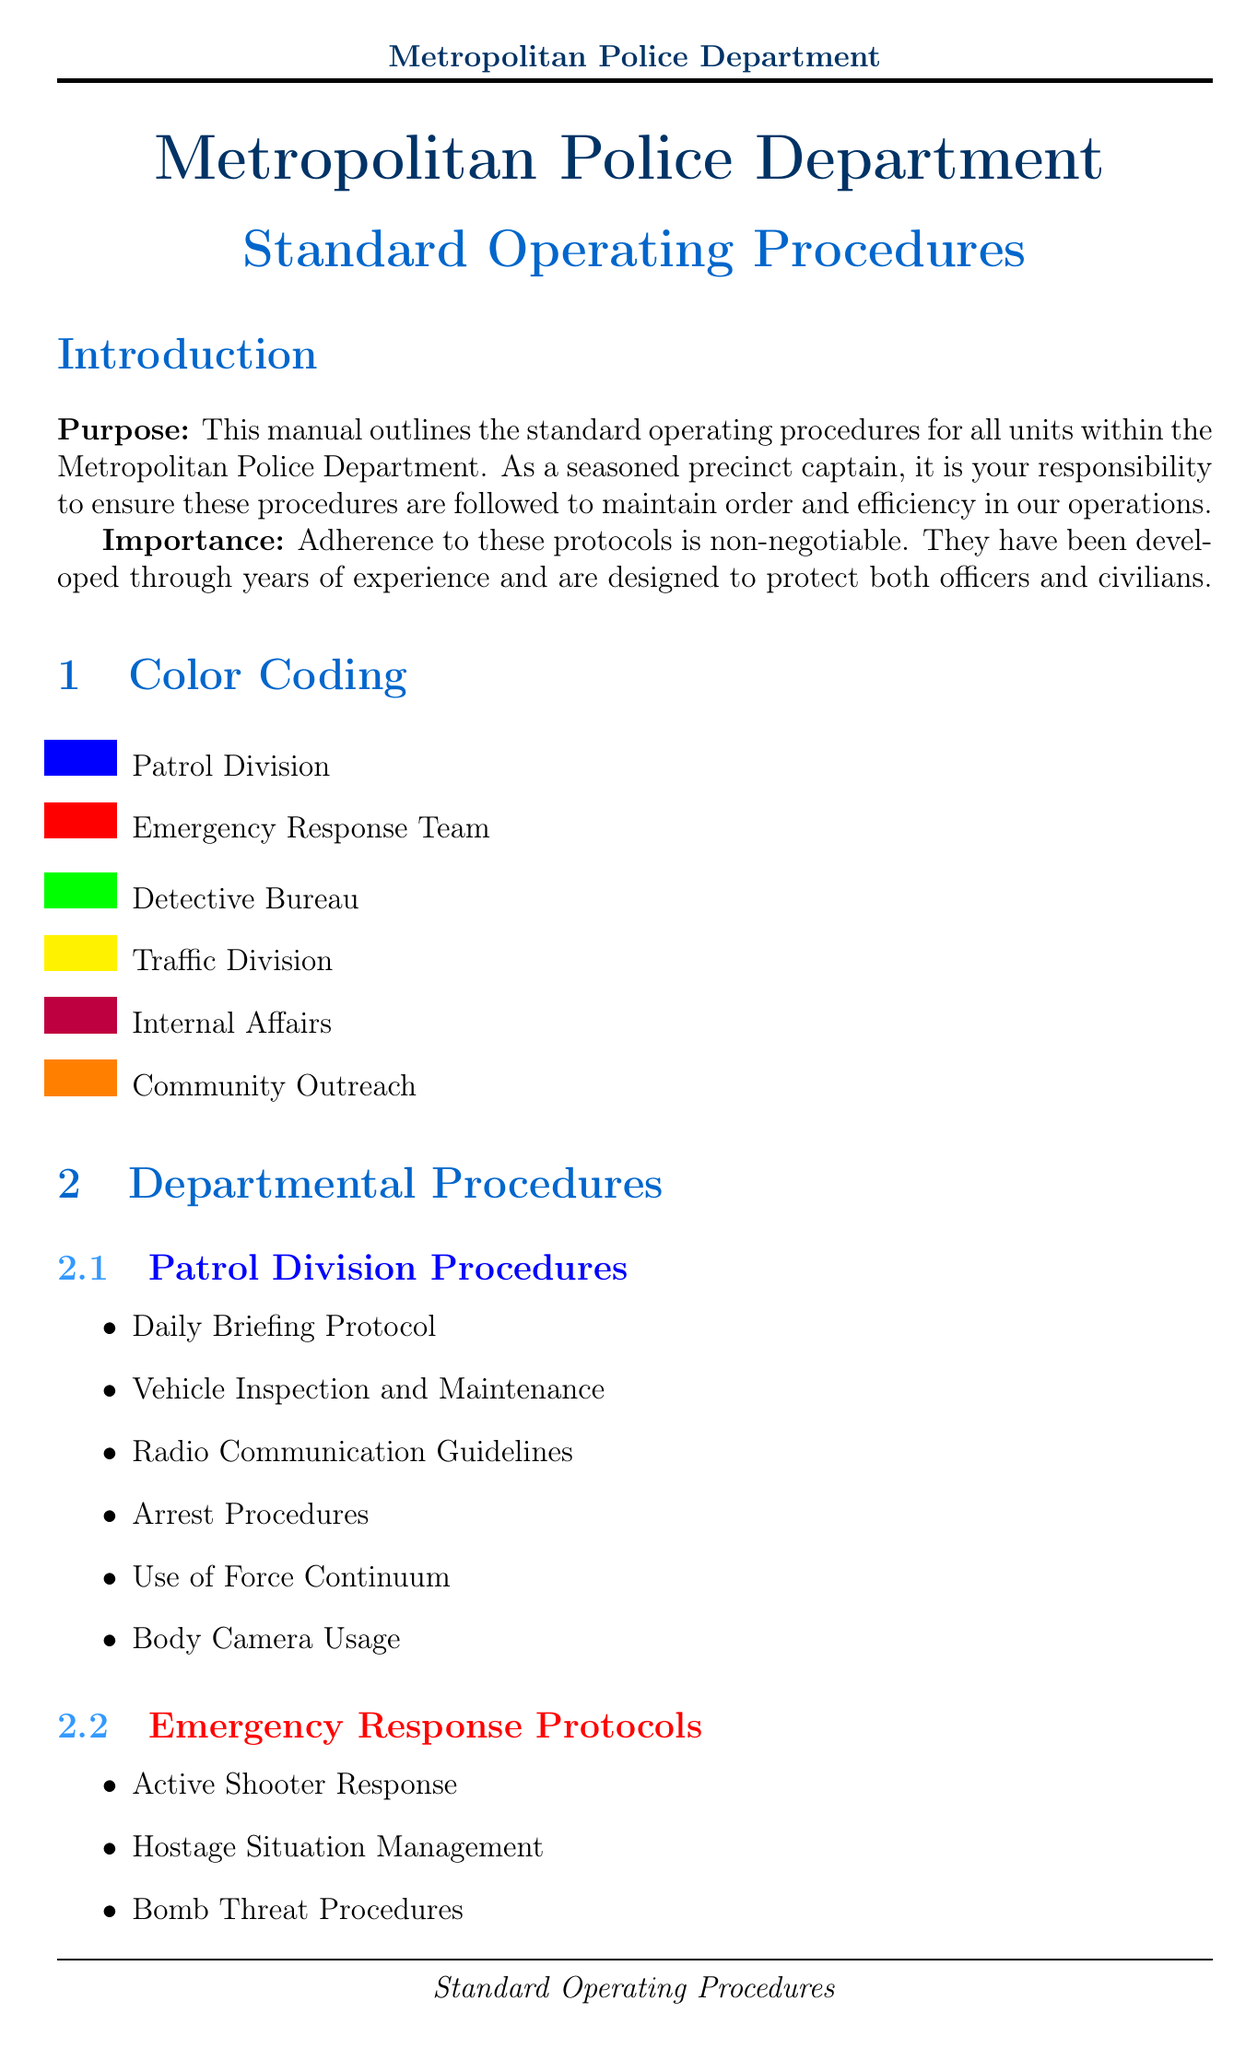What is the manual title? The manual title is explicitly mentioned at the top of the document to indicate its content.
Answer: Metropolitan Police Department Standard Operating Procedures What color represents the Emergency Response Team? The color coding section includes colors assigned to different units, highlighting each respective unit in the manual.
Answer: Red How many subsections are in the Traffic Division Regulations? The number of subsections is counted from the Traffic Division Regulations listed in the document.
Answer: Six What is the purpose of this manual? The purpose is defined in the introduction, outlining the general objective of the document for law enforcement personnel.
Answer: To outline standard operating procedures What date was the Use of Force Continuum updated? The specific date for changes made to the Use of Force Continuum is noted in the revision history section of the document.
Answer: 2023-05-15 What action should be taken during a Code Green situation? The response to each code is outlined for clarity, indicating specific actions to be taken in emergencies.
Answer: Establish perimeter What type of procedures are included under Internal Affairs Protocols? This section describes the specific procedures related to internal investigations within the department.
Answer: Officer Complaint Investigation How many emergency protocols are listed in the document? The emergency protocols section provides a clear list of coded responses, which can be counted for the total.
Answer: Five What initiative involves the Citizen Police Academy? This initiative is specifically part of the Community Outreach section, highlighting its community engagement efforts.
Answer: Community Outreach Initiatives 